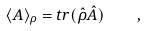Convert formula to latex. <formula><loc_0><loc_0><loc_500><loc_500>\langle A \rangle _ { \rho } = t r ( \hat { \rho } \hat { A } ) \quad ,</formula> 